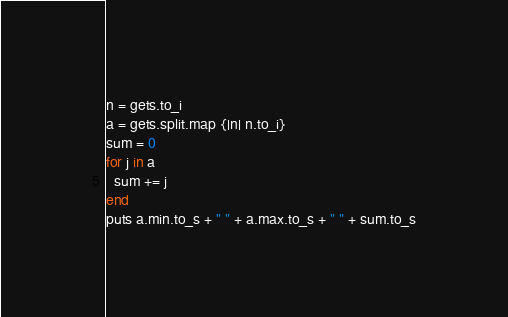<code> <loc_0><loc_0><loc_500><loc_500><_Ruby_>n = gets.to_i
a = gets.split.map {|n| n.to_i}
sum = 0
for j in a
  sum += j
end
puts a.min.to_s + " " + a.max.to_s + " " + sum.to_s</code> 